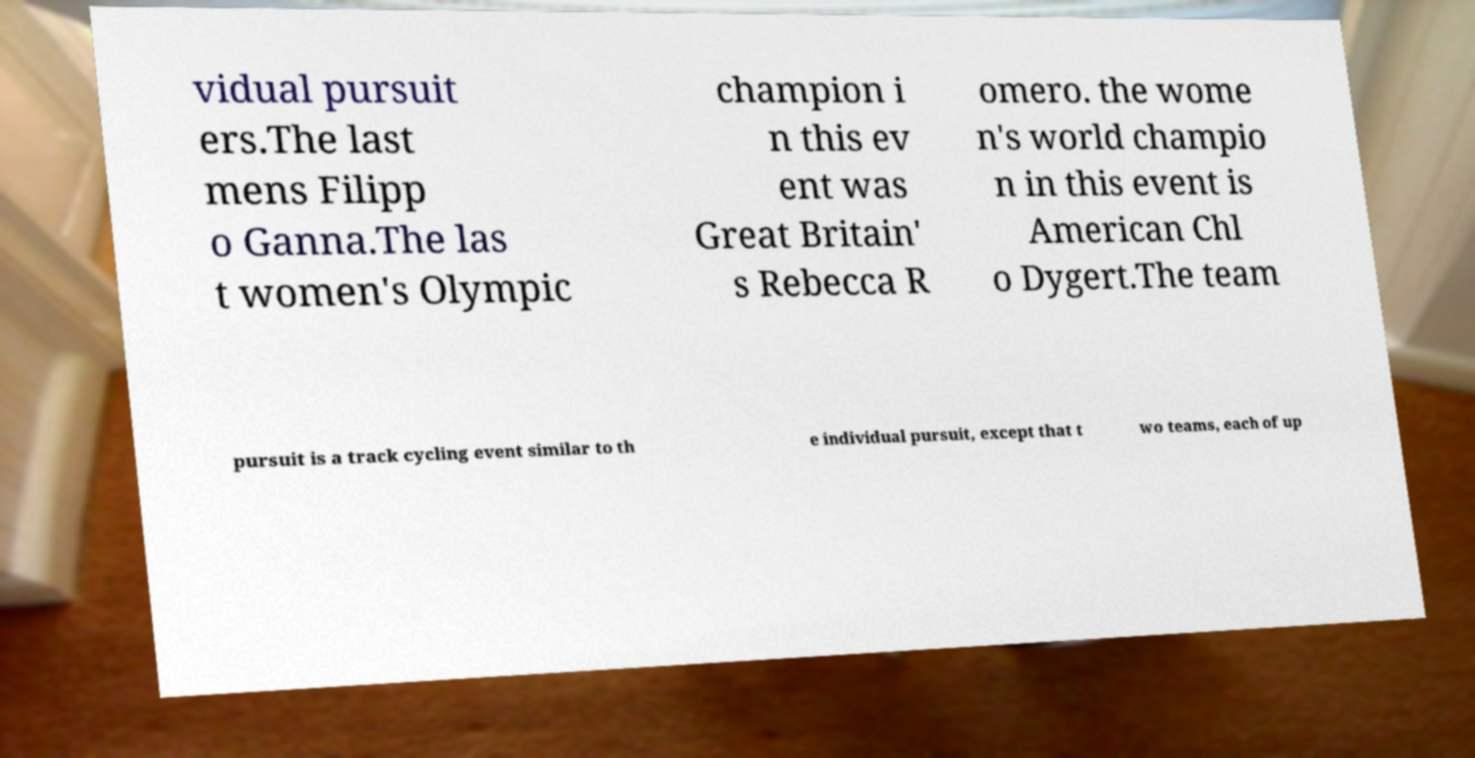Can you accurately transcribe the text from the provided image for me? vidual pursuit ers.The last mens Filipp o Ganna.The las t women's Olympic champion i n this ev ent was Great Britain' s Rebecca R omero. the wome n's world champio n in this event is American Chl o Dygert.The team pursuit is a track cycling event similar to th e individual pursuit, except that t wo teams, each of up 